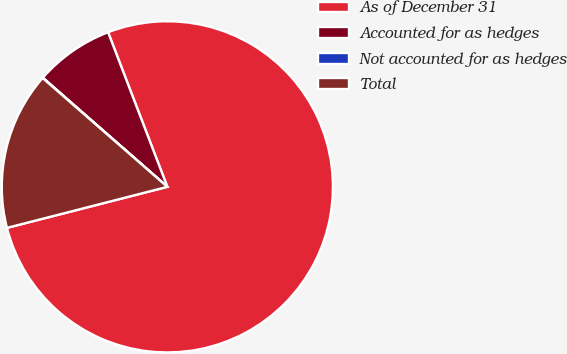Convert chart to OTSL. <chart><loc_0><loc_0><loc_500><loc_500><pie_chart><fcel>As of December 31<fcel>Accounted for as hedges<fcel>Not accounted for as hedges<fcel>Total<nl><fcel>76.84%<fcel>7.72%<fcel>0.04%<fcel>15.4%<nl></chart> 